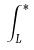<formula> <loc_0><loc_0><loc_500><loc_500>\int _ { L } ^ { * }</formula> 